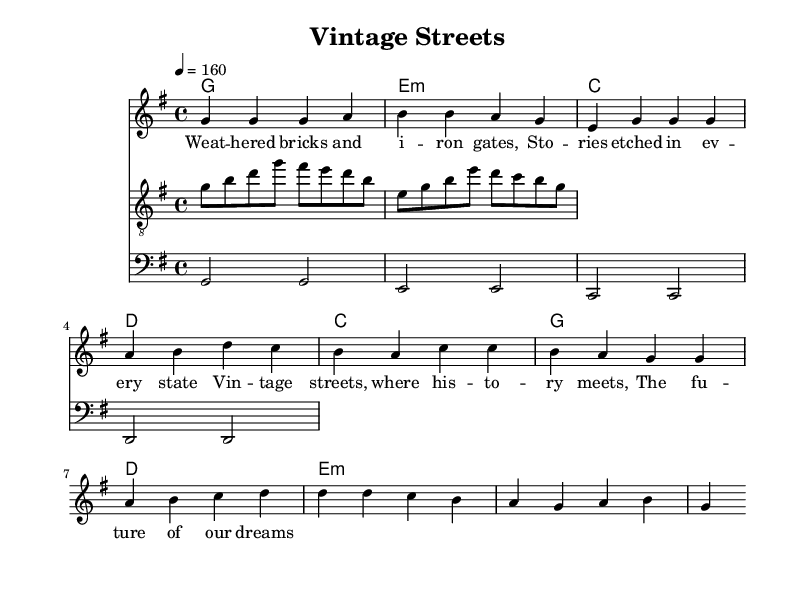What is the key signature of this music? The key signature is G major, which has one sharp (F#). It is noted at the beginning of the staff.
Answer: G major What is the time signature of this song? The time signature is 4/4, indicating four beats per measure. This is also indicated at the beginning of the sheet music.
Answer: 4/4 What is the tempo marking of the piece? The tempo is marked at 160 beats per minute, indicated by the tempo notation (4 = 160) at the start of the score.
Answer: 160 How many measures are in the verse section? Counting the measures for the verse, there are four measures in total. The music shows distinct sections marked for the verse and chorus.
Answer: 4 Which chords are used during the chorus? The chords in the chorus are C, G, D, and E minor, which are indicated in the chord names section above the melody.
Answer: C, G, D, E minor What type of musical form does this song follow? The song follows a verse-chorus structure, typical in pop-punk, where the melody alternates between the verses and the chorus sections.
Answer: Verse-Chorus What rhythmic value is predominant in the guitar riff section? The predominant rhythmic value in the guitar riff is eighth notes, as seen from the use of the note lengths throughout the riff's notation.
Answer: Eighth notes 